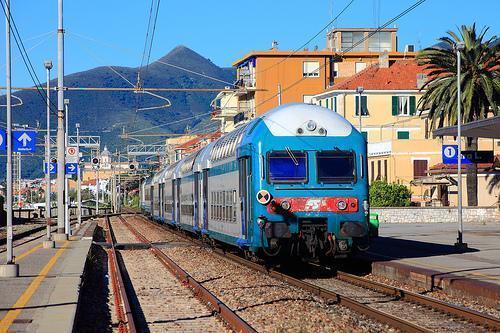How many tracks are there?
Give a very brief answer. 2. 